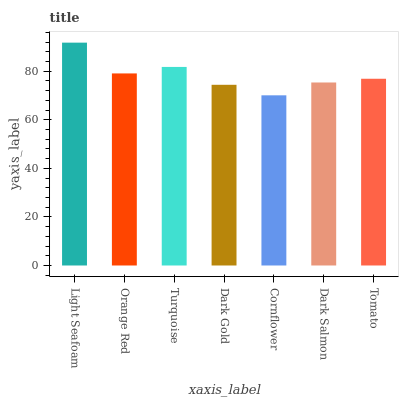Is Cornflower the minimum?
Answer yes or no. Yes. Is Light Seafoam the maximum?
Answer yes or no. Yes. Is Orange Red the minimum?
Answer yes or no. No. Is Orange Red the maximum?
Answer yes or no. No. Is Light Seafoam greater than Orange Red?
Answer yes or no. Yes. Is Orange Red less than Light Seafoam?
Answer yes or no. Yes. Is Orange Red greater than Light Seafoam?
Answer yes or no. No. Is Light Seafoam less than Orange Red?
Answer yes or no. No. Is Tomato the high median?
Answer yes or no. Yes. Is Tomato the low median?
Answer yes or no. Yes. Is Dark Salmon the high median?
Answer yes or no. No. Is Orange Red the low median?
Answer yes or no. No. 